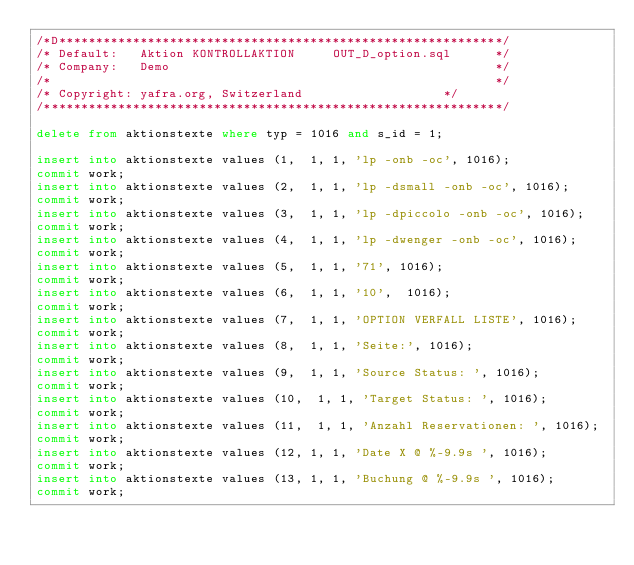Convert code to text. <code><loc_0><loc_0><loc_500><loc_500><_SQL_>/*D************************************************************/
/* Default:   Aktion KONTROLLAKTION     OUT_D_option.sql      */
/* Company:   Demo                                            */
/*                                                            */              
/* Copyright: yafra.org, Switzerland                   */
/**************************************************************/
 
delete from aktionstexte where typ = 1016 and s_id = 1;

insert into aktionstexte values (1,  1, 1, 'lp -onb -oc', 1016);
commit work;
insert into aktionstexte values (2,  1, 1, 'lp -dsmall -onb -oc', 1016);
commit work;
insert into aktionstexte values (3,  1, 1, 'lp -dpiccolo -onb -oc', 1016);
commit work;
insert into aktionstexte values (4,  1, 1, 'lp -dwenger -onb -oc', 1016);
commit work;
insert into aktionstexte values (5,  1, 1, '71', 1016);
commit work;
insert into aktionstexte values (6,  1, 1, '10',  1016);
commit work;
insert into aktionstexte values (7,  1, 1, 'OPTION VERFALL LISTE', 1016);
commit work;
insert into aktionstexte values (8,  1, 1, 'Seite:', 1016);
commit work;
insert into aktionstexte values (9,  1, 1, 'Source Status: ', 1016);
commit work;
insert into aktionstexte values (10,  1, 1, 'Target Status: ', 1016);
commit work;
insert into aktionstexte values (11,  1, 1, 'Anzahl Reservationen: ', 1016);
commit work;
insert into aktionstexte values (12, 1, 1, 'Date X @ %-9.9s ', 1016);
commit work;
insert into aktionstexte values (13, 1, 1, 'Buchung @ %-9.9s ', 1016);
commit work;</code> 